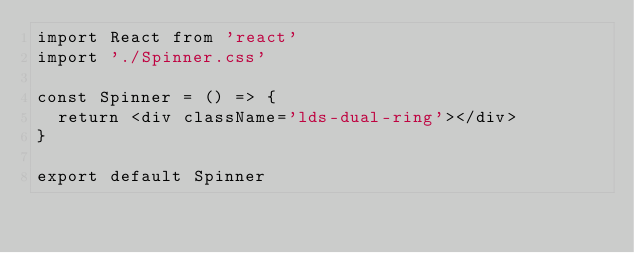Convert code to text. <code><loc_0><loc_0><loc_500><loc_500><_JavaScript_>import React from 'react'
import './Spinner.css'

const Spinner = () => {
	return <div className='lds-dual-ring'></div>
}

export default Spinner
</code> 